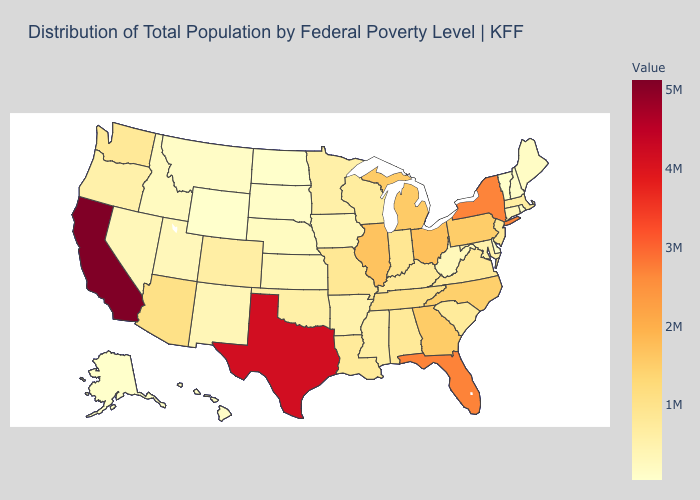Does Nebraska have the highest value in the USA?
Give a very brief answer. No. Does New York have the highest value in the Northeast?
Be succinct. Yes. Does Connecticut have the lowest value in the Northeast?
Keep it brief. No. Does Michigan have the highest value in the USA?
Short answer required. No. Does Delaware have the highest value in the USA?
Quick response, please. No. 